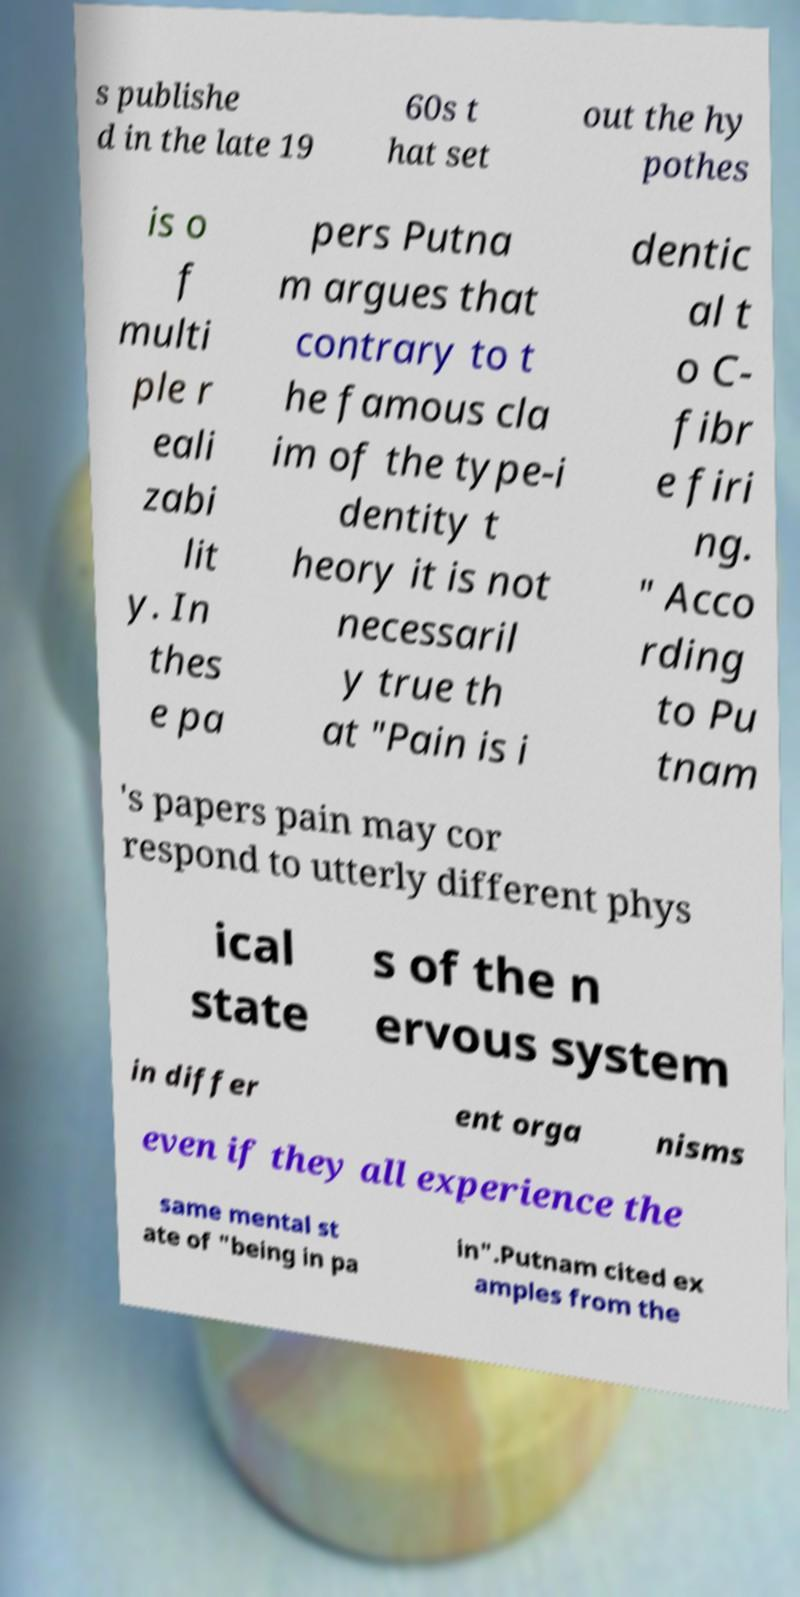There's text embedded in this image that I need extracted. Can you transcribe it verbatim? s publishe d in the late 19 60s t hat set out the hy pothes is o f multi ple r eali zabi lit y. In thes e pa pers Putna m argues that contrary to t he famous cla im of the type-i dentity t heory it is not necessaril y true th at "Pain is i dentic al t o C- fibr e firi ng. " Acco rding to Pu tnam 's papers pain may cor respond to utterly different phys ical state s of the n ervous system in differ ent orga nisms even if they all experience the same mental st ate of "being in pa in".Putnam cited ex amples from the 